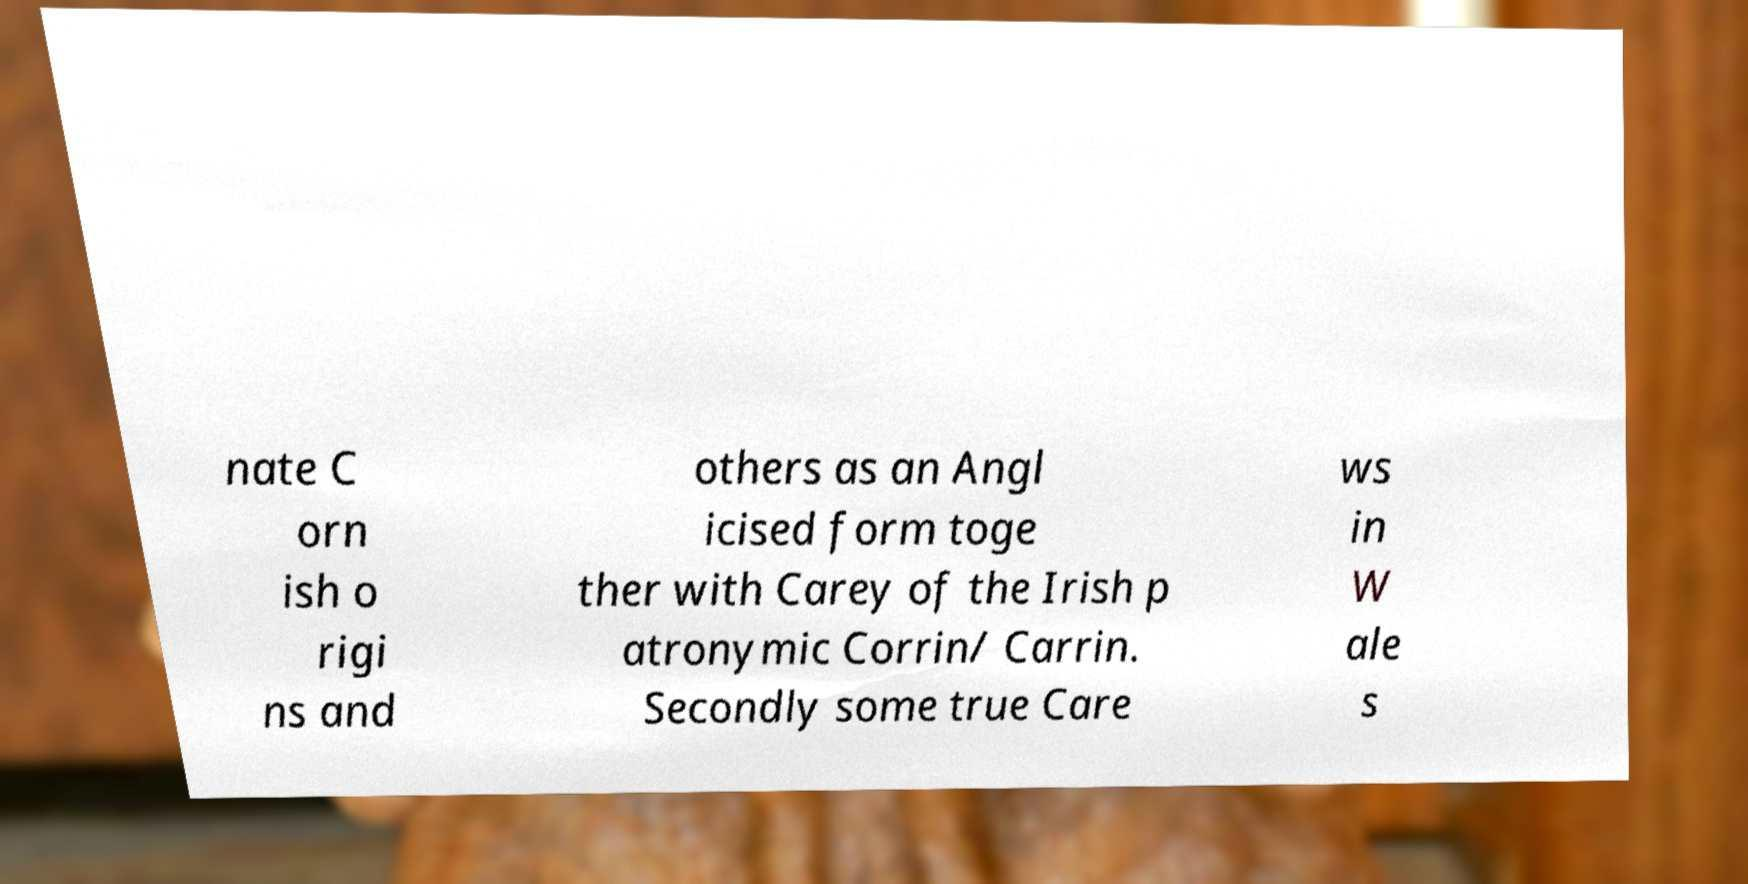For documentation purposes, I need the text within this image transcribed. Could you provide that? nate C orn ish o rigi ns and others as an Angl icised form toge ther with Carey of the Irish p atronymic Corrin/ Carrin. Secondly some true Care ws in W ale s 